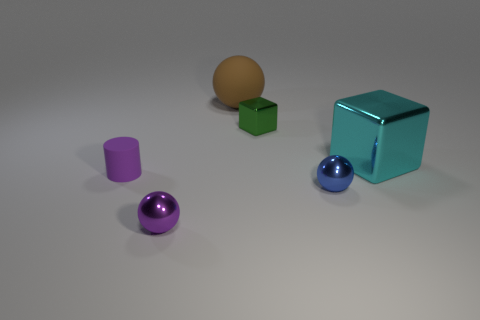Add 1 small green metal blocks. How many objects exist? 7 Subtract all cubes. How many objects are left? 4 Add 1 large metallic cubes. How many large metallic cubes are left? 2 Add 3 small purple rubber balls. How many small purple rubber balls exist? 3 Subtract 0 purple blocks. How many objects are left? 6 Subtract all blue blocks. Subtract all purple balls. How many objects are left? 5 